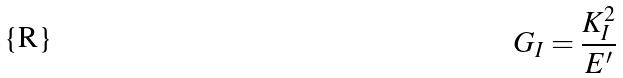<formula> <loc_0><loc_0><loc_500><loc_500>G _ { I } = \frac { K _ { I } ^ { 2 } } { E ^ { \prime } }</formula> 